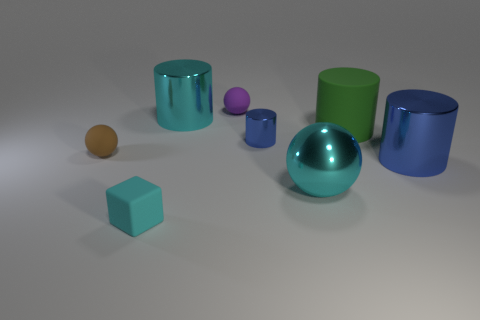How many tiny purple spheres are right of the shiny cylinder in front of the tiny object to the right of the purple object? In the image, there are no tiny purple spheres located to the right of the shiny cylinder that is situated in front of the tiny object to the right of the larger purple cylinder. Therefore, the answer is '0'. To give you a better sense of the scene, the tiny object you mentioned is a small purple sphere, and it's to the right of a purple cylinder, which is one of the many vibrant objects that are spread out in the space. 